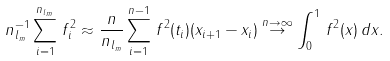<formula> <loc_0><loc_0><loc_500><loc_500>n _ { l _ { m } } ^ { - 1 } \sum _ { i = 1 } ^ { n _ { l _ { m } } } \, f _ { i } ^ { 2 } \approx \frac { n } { n _ { l _ { m } } } \sum _ { i = 1 } ^ { n - 1 } \, f ^ { 2 } ( t _ { i } ) ( x _ { i + 1 } - x _ { i } ) \stackrel { n \to \infty } { \to } \int _ { 0 } ^ { 1 } \, f ^ { 2 } ( x ) \, d x .</formula> 